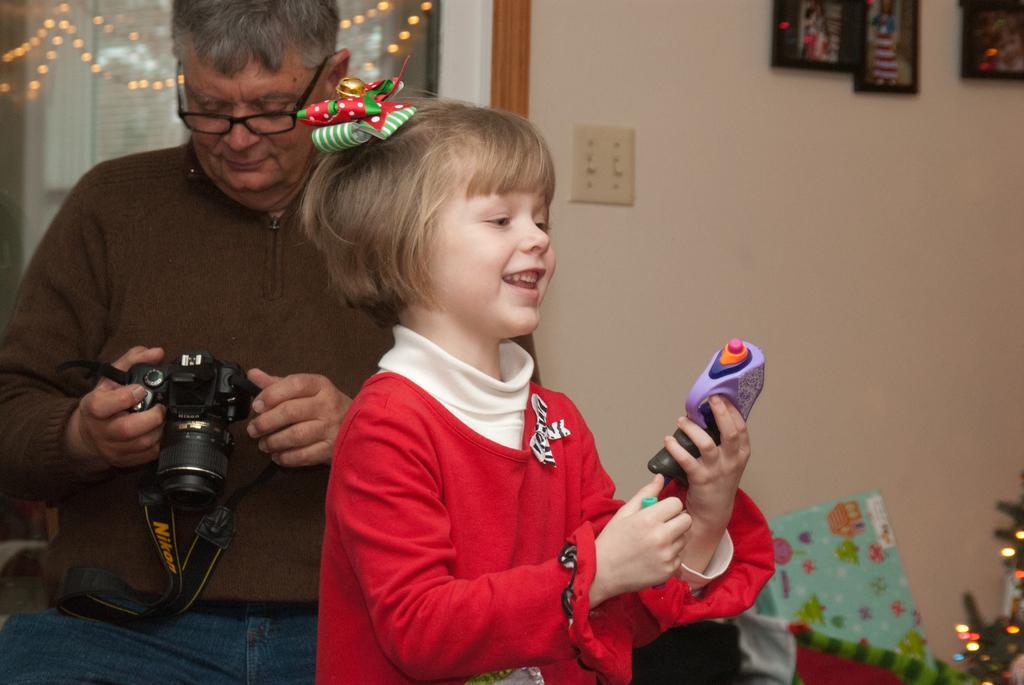In one or two sentences, can you explain what this image depicts? On the background we can see photo frames over a wall and these are lights. Here we can see a man wearing spectacles holding a camera in his hands and starting to it. Here we can see a girl smiling and she is holding a toy in her hands. 